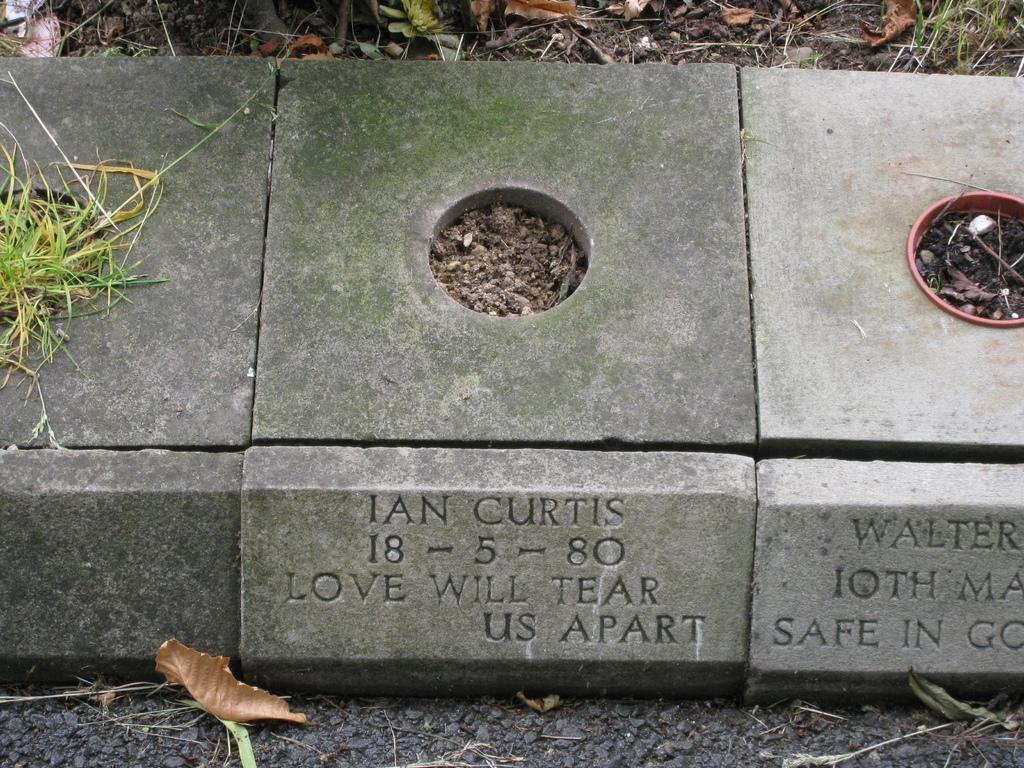What type of objects are on the ground in the image? There are memorial stones with a hole in the center on the ground. What is attached to the memorial stones? There is another stone with text attached to the memorial stones. How many buns can be seen on the ground in the image? There are no buns present in the image; it features memorial stones with a hole in the center and another stone with text. What type of class is being held near the memorial stones in the image? There is no class or any indication of a class being held in the image. 